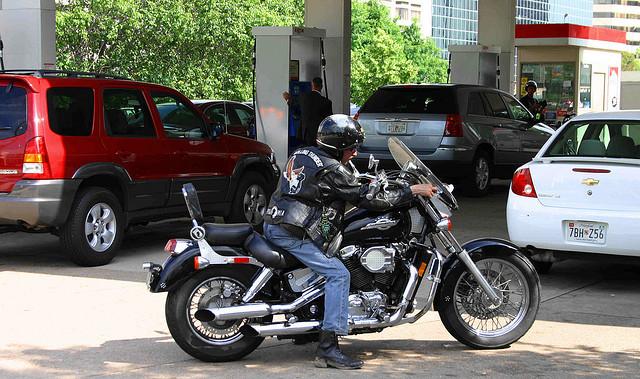Is this a man or woman?
Give a very brief answer. Man. How many buses can be seen in this picture?
Short answer required. 0. What number in line is the motorcyclist?
Quick response, please. 2. Which car part, on most of the vehicles seen, matches the red SUV?
Answer briefly. Tires. 